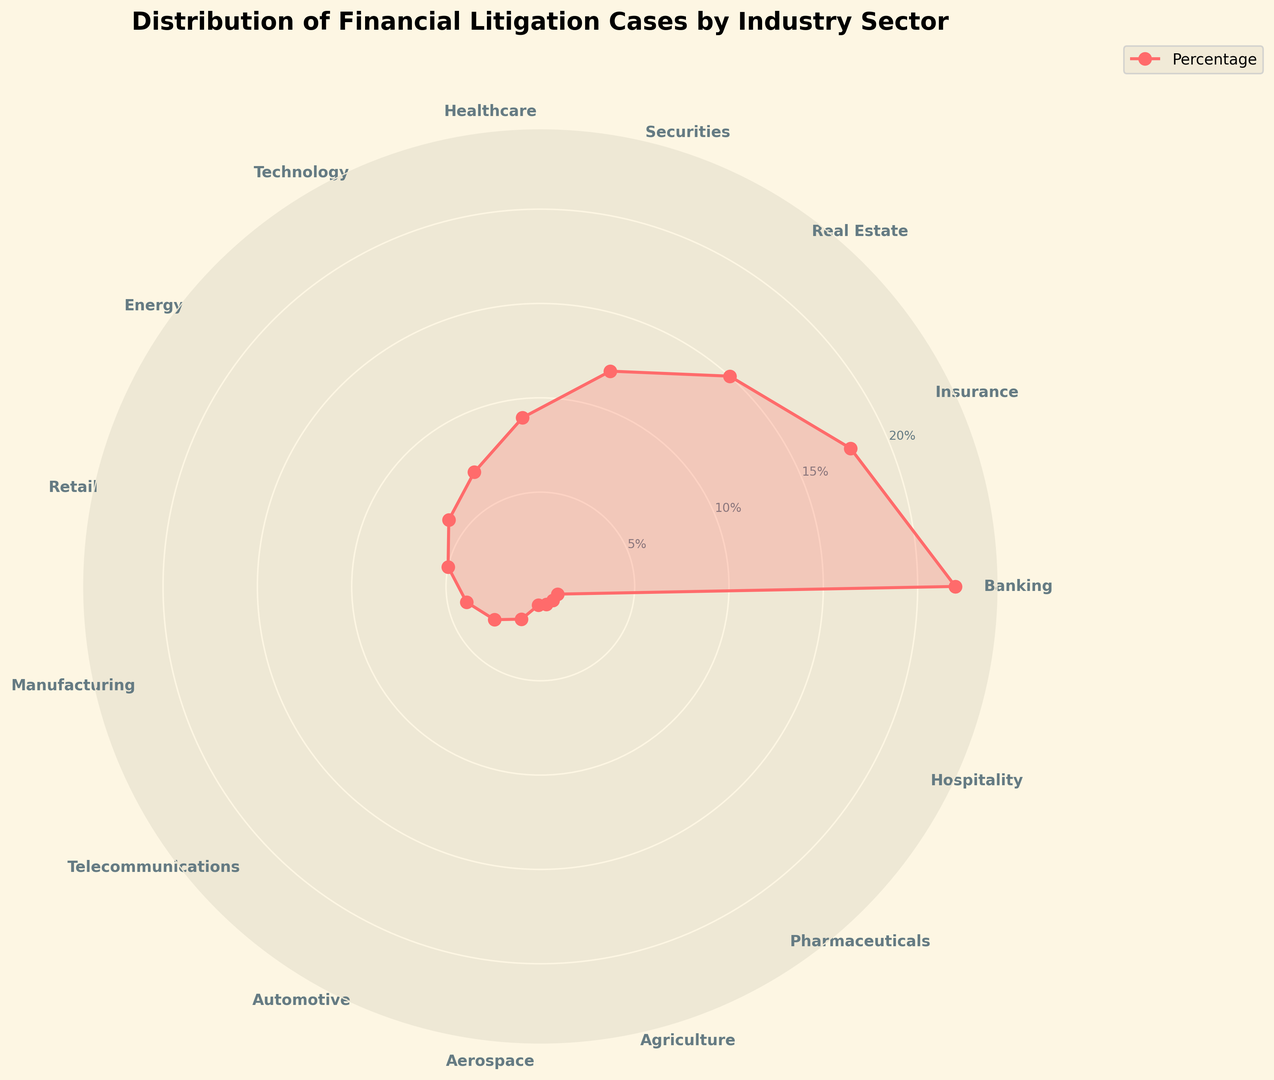What's the industry with the highest percentage of financial litigation cases? The chart shows percentages distributed among different industries. By looking at the peaks, Banking stands out as the highest.
Answer: Banking Which industry sector has a lower percentage than Technology but higher than Retail? First, identify the percentages for Technology (7%) and Retail (5%). The industry between them is Energy (6%).
Answer: Energy Combine the percentages of Healthcare, Technology, and Energy. What is the result? Adding the percentages: Healthcare (9%) + Technology (7%) + Energy (6%) = 22%
Answer: 22% Which sectors have the smallest slices in the chart? The smallest slices are visible at the bottom right, representing 1% each: Aerospace, Agriculture, Pharmaceuticals, and Hospitality.
Answer: Aerospace, Agriculture, Pharmaceuticals, Hospitality Compare the size of the Banking and Securities sectors. How much bigger is the Banking sector in percentage points? Banking is at 22% and Securities at 12%. The difference is 22% - 12% = 10%.
Answer: 10% Is the Technology sector larger or smaller than the Real Estate sector? Technology has 7%, and Real Estate has 15%, so Technology is smaller.
Answer: Smaller Sum the percentages of the three smallest sectors. The smallest sectors are each 1%: Aerospace (1%) + Agriculture (1%) + Pharmaceuticals (1%) = 3%.
Answer: 3% If you combine the total percentages of the top three sectors, what do you get? Top three sectors' percentages: Banking (22%) + Insurance (18%) + Real Estate (15%) = 55%.
Answer: 55% What is the sum of the percentages for the following industries: Automotive, Retail, and Manufacturing? Automotive (2%) + Retail (5%) + Manufacturing (4%) = 11%.
Answer: 11% Compare Retail and Telecommunications sectors. How much is the difference in their percentages? Retail is at 5%, and Telecommunications is at 3%. The difference is 5% - 3% = 2%.
Answer: 2% 